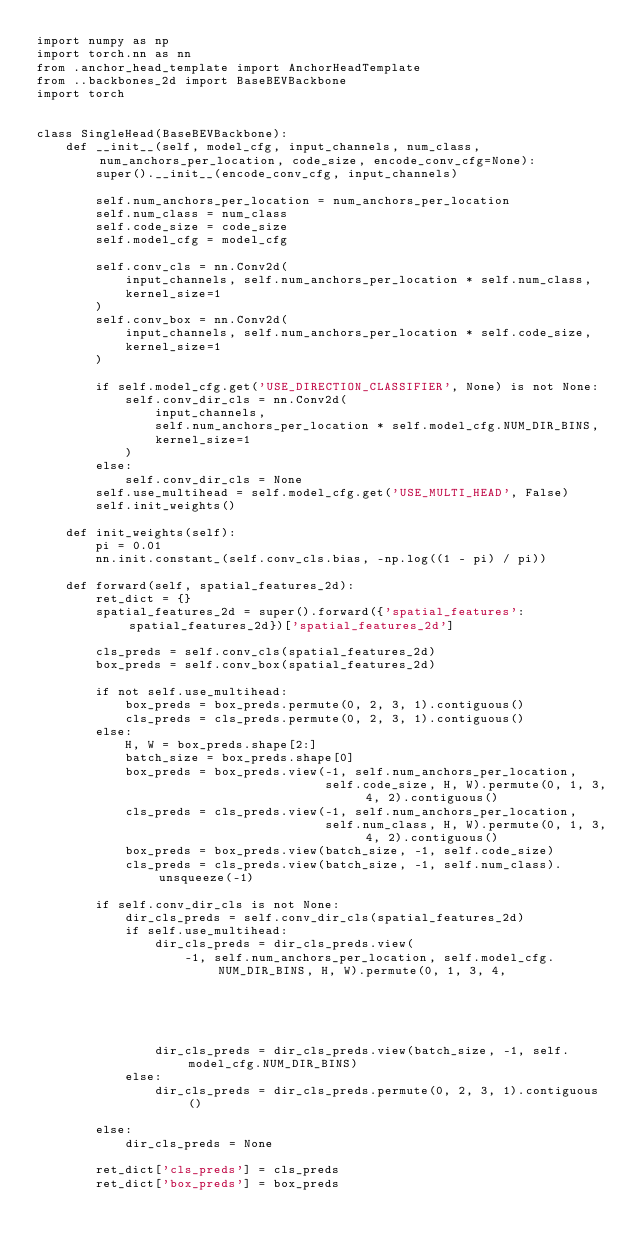<code> <loc_0><loc_0><loc_500><loc_500><_Python_>import numpy as np
import torch.nn as nn
from .anchor_head_template import AnchorHeadTemplate
from ..backbones_2d import BaseBEVBackbone
import torch


class SingleHead(BaseBEVBackbone):
    def __init__(self, model_cfg, input_channels, num_class, num_anchors_per_location, code_size, encode_conv_cfg=None):
        super().__init__(encode_conv_cfg, input_channels)

        self.num_anchors_per_location = num_anchors_per_location
        self.num_class = num_class
        self.code_size = code_size
        self.model_cfg = model_cfg

        self.conv_cls = nn.Conv2d(
            input_channels, self.num_anchors_per_location * self.num_class,
            kernel_size=1
        )
        self.conv_box = nn.Conv2d(
            input_channels, self.num_anchors_per_location * self.code_size,
            kernel_size=1
        )

        if self.model_cfg.get('USE_DIRECTION_CLASSIFIER', None) is not None:
            self.conv_dir_cls = nn.Conv2d(
                input_channels,
                self.num_anchors_per_location * self.model_cfg.NUM_DIR_BINS,
                kernel_size=1
            )
        else:
            self.conv_dir_cls = None
        self.use_multihead = self.model_cfg.get('USE_MULTI_HEAD', False)
        self.init_weights()

    def init_weights(self):
        pi = 0.01
        nn.init.constant_(self.conv_cls.bias, -np.log((1 - pi) / pi))

    def forward(self, spatial_features_2d):
        ret_dict = {}
        spatial_features_2d = super().forward({'spatial_features': spatial_features_2d})['spatial_features_2d']

        cls_preds = self.conv_cls(spatial_features_2d)
        box_preds = self.conv_box(spatial_features_2d)

        if not self.use_multihead:
            box_preds = box_preds.permute(0, 2, 3, 1).contiguous()
            cls_preds = cls_preds.permute(0, 2, 3, 1).contiguous()
        else:
            H, W = box_preds.shape[2:]
            batch_size = box_preds.shape[0]
            box_preds = box_preds.view(-1, self.num_anchors_per_location,
                                       self.code_size, H, W).permute(0, 1, 3, 4, 2).contiguous()
            cls_preds = cls_preds.view(-1, self.num_anchors_per_location,
                                       self.num_class, H, W).permute(0, 1, 3, 4, 2).contiguous()
            box_preds = box_preds.view(batch_size, -1, self.code_size)
            cls_preds = cls_preds.view(batch_size, -1, self.num_class).unsqueeze(-1)

        if self.conv_dir_cls is not None:
            dir_cls_preds = self.conv_dir_cls(spatial_features_2d)
            if self.use_multihead:
                dir_cls_preds = dir_cls_preds.view(
                    -1, self.num_anchors_per_location, self.model_cfg.NUM_DIR_BINS, H, W).permute(0, 1, 3, 4,
                                                                                                  2).contiguous()
                dir_cls_preds = dir_cls_preds.view(batch_size, -1, self.model_cfg.NUM_DIR_BINS)
            else:
                dir_cls_preds = dir_cls_preds.permute(0, 2, 3, 1).contiguous()

        else:
            dir_cls_preds = None

        ret_dict['cls_preds'] = cls_preds
        ret_dict['box_preds'] = box_preds</code> 